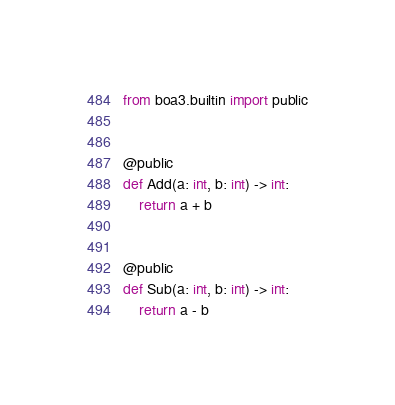Convert code to text. <code><loc_0><loc_0><loc_500><loc_500><_Python_>from boa3.builtin import public


@public
def Add(a: int, b: int) -> int:
    return a + b


@public
def Sub(a: int, b: int) -> int:
    return a - b
</code> 